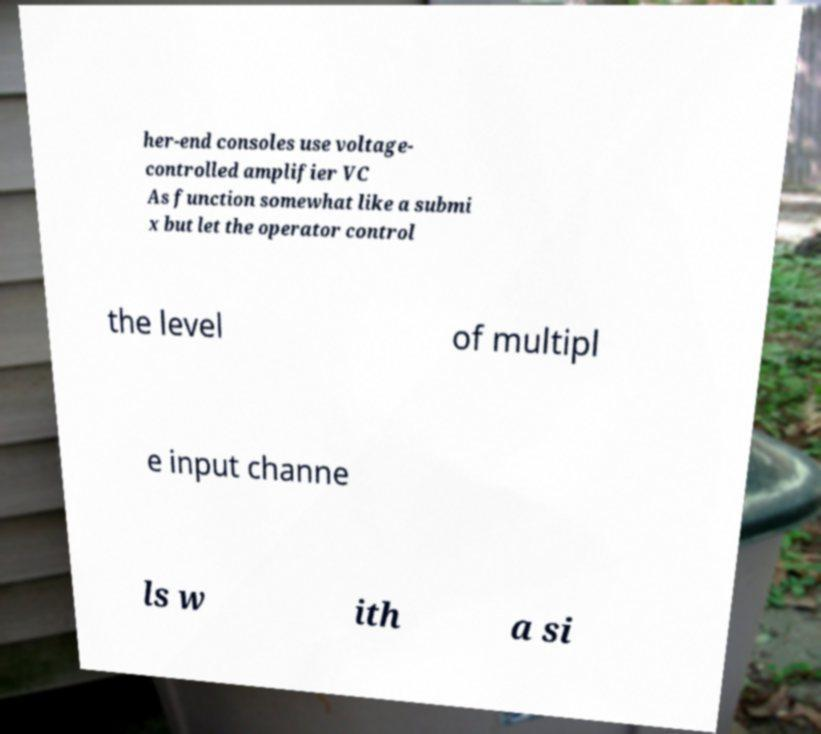Please read and relay the text visible in this image. What does it say? her-end consoles use voltage- controlled amplifier VC As function somewhat like a submi x but let the operator control the level of multipl e input channe ls w ith a si 